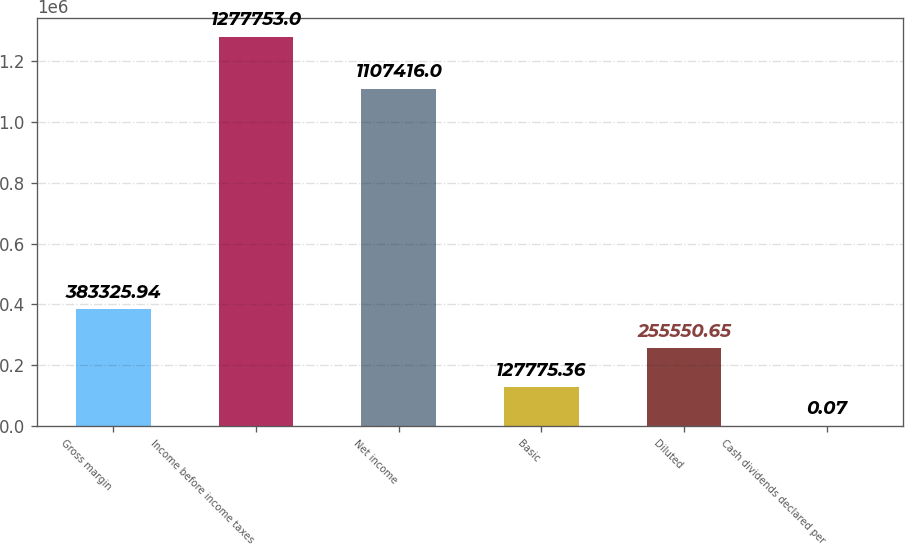Convert chart. <chart><loc_0><loc_0><loc_500><loc_500><bar_chart><fcel>Gross margin<fcel>Income before income taxes<fcel>Net income<fcel>Basic<fcel>Diluted<fcel>Cash dividends declared per<nl><fcel>383326<fcel>1.27775e+06<fcel>1.10742e+06<fcel>127775<fcel>255551<fcel>0.07<nl></chart> 